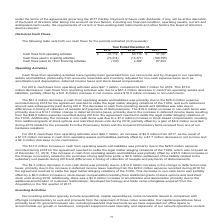From Alarmcom Holdings's financial document, Which years does the table provide information for the company's cash flows for? The document contains multiple relevant values: 2019, 2018, 2017. From the document: "Year Ended December 31, 2019 2018 2017 Cash flows from operating activities $ 47,112 $ 60,710 $ 57,187 Cash flows used in investing activi Year Ended ..." Also, What was the Cash flows (used in) / from financing activities in 2019? According to the financial document, (130) (in thousands). The relevant text states: ") Cash flows (used in) / from financing activities (130) 2,399 67,303..." Also, What was the Cash flows used in investing activities in 2017 According to the financial document, (168,795) (in thousands). The relevant text states: "ows used in investing activities (73,414) (13,377) (168,795) Cash flows (used in) / from financing activities (130) 2,399 67,303..." Also, can you calculate: What was the change in Cash flows from operating activities between 2017 and 2018? Based on the calculation: 60,710-57,187, the result is 3523 (in thousands). This is based on the information: "ows from operating activities $ 47,112 $ 60,710 $ 57,187 Cash flows used in investing activities (73,414) (13,377) (168,795) Cash flows (used in) / from fin 7 Cash flows from operating activities $ 47..." The key data points involved are: 57,187, 60,710. Also, can you calculate: What was the sum of cash flows in 2019? Based on the calculation: 47,112-73,414-130, the result is -26432 (in thousands). This is based on the information: "Cash flows (used in) / from financing activities (130) 2,399 67,303 $ 57,187 Cash flows used in investing activities (73,414) (13,377) (168,795) Cash flows (used in) / from financing activities (130) ..." The key data points involved are: 130, 47,112, 73,414. Also, can you calculate: What was the percentage change in the Cash flows (used in) / from financing activities between 2017 and 2018? To answer this question, I need to perform calculations using the financial data. The calculation is: (2,399-67,303)/67,303, which equals -96.44 (percentage). This is based on the information: "flows (used in) / from financing activities (130) 2,399 67,303 (used in) / from financing activities (130) 2,399 67,303..." The key data points involved are: 2,399, 67,303. 